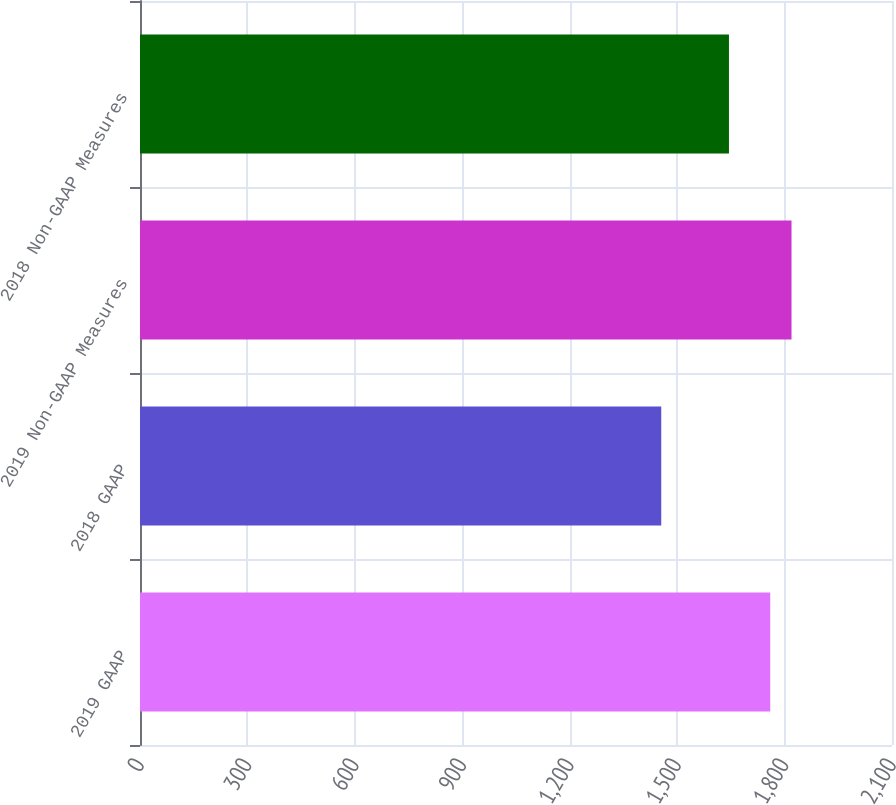<chart> <loc_0><loc_0><loc_500><loc_500><bar_chart><fcel>2019 GAAP<fcel>2018 GAAP<fcel>2019 Non-GAAP Measures<fcel>2018 Non-GAAP Measures<nl><fcel>1760<fcel>1455.6<fcel>1819.4<fcel>1644.7<nl></chart> 